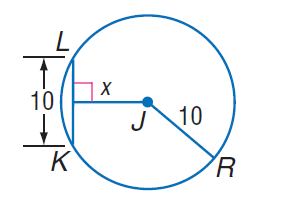Question: Find x.
Choices:
A. 5
B. 5 \sqrt { 3 }
C. 10
D. 15
Answer with the letter. Answer: B 